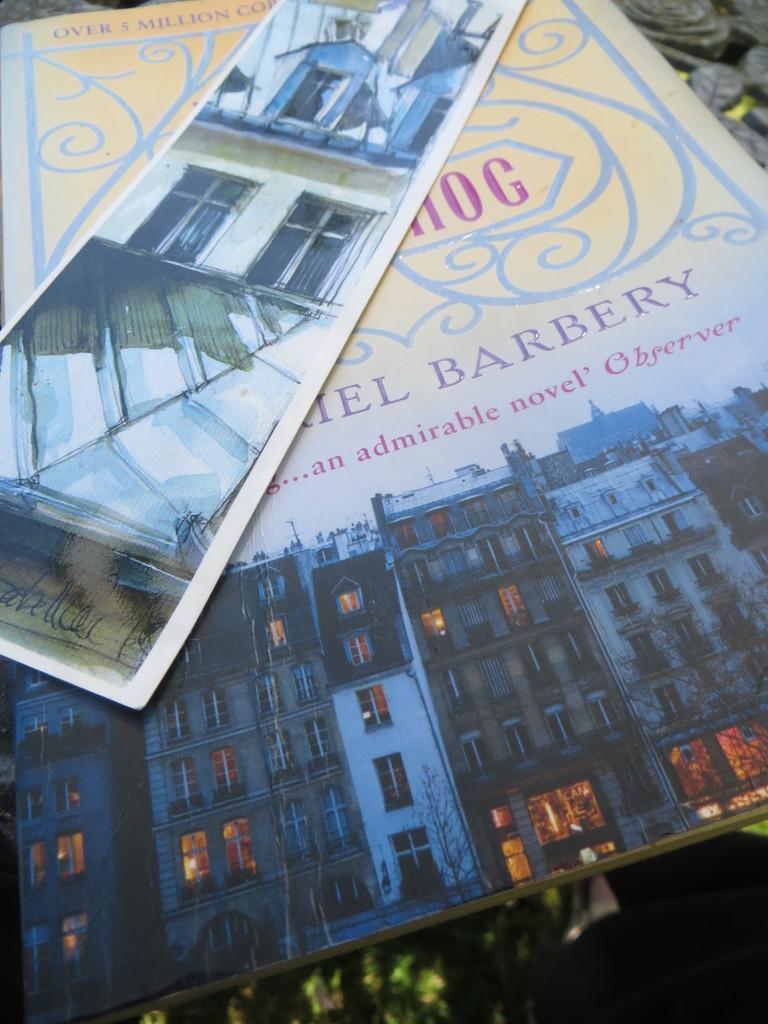In one or two sentences, can you explain what this image depicts? In the picture I can see a book. I can see the drawing of a building on the book. 